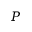Convert formula to latex. <formula><loc_0><loc_0><loc_500><loc_500>P</formula> 